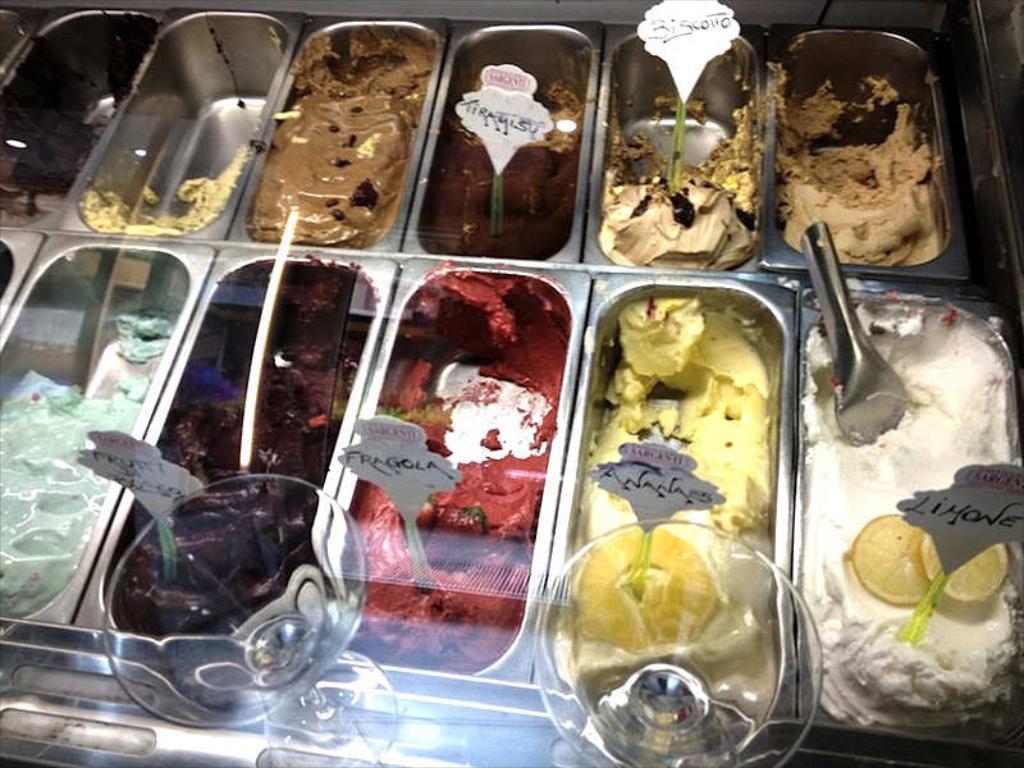In one or two sentences, can you explain what this image depicts? In this image I can see few Ice cream pastes which are placed in the bowls. At the bottom of the image I can see the glass. 